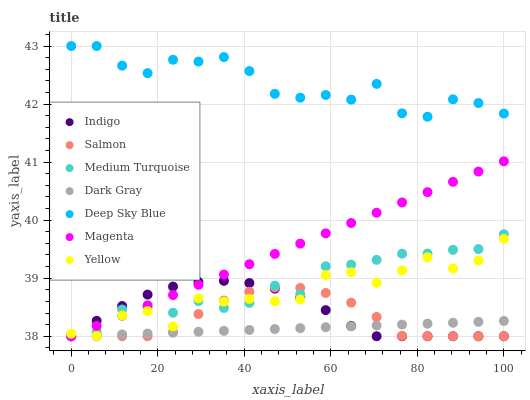Does Dark Gray have the minimum area under the curve?
Answer yes or no. Yes. Does Deep Sky Blue have the maximum area under the curve?
Answer yes or no. Yes. Does Medium Turquoise have the minimum area under the curve?
Answer yes or no. No. Does Medium Turquoise have the maximum area under the curve?
Answer yes or no. No. Is Dark Gray the smoothest?
Answer yes or no. Yes. Is Yellow the roughest?
Answer yes or no. Yes. Is Medium Turquoise the smoothest?
Answer yes or no. No. Is Medium Turquoise the roughest?
Answer yes or no. No. Does Indigo have the lowest value?
Answer yes or no. Yes. Does Yellow have the lowest value?
Answer yes or no. No. Does Deep Sky Blue have the highest value?
Answer yes or no. Yes. Does Medium Turquoise have the highest value?
Answer yes or no. No. Is Medium Turquoise less than Deep Sky Blue?
Answer yes or no. Yes. Is Deep Sky Blue greater than Magenta?
Answer yes or no. Yes. Does Salmon intersect Medium Turquoise?
Answer yes or no. Yes. Is Salmon less than Medium Turquoise?
Answer yes or no. No. Is Salmon greater than Medium Turquoise?
Answer yes or no. No. Does Medium Turquoise intersect Deep Sky Blue?
Answer yes or no. No. 